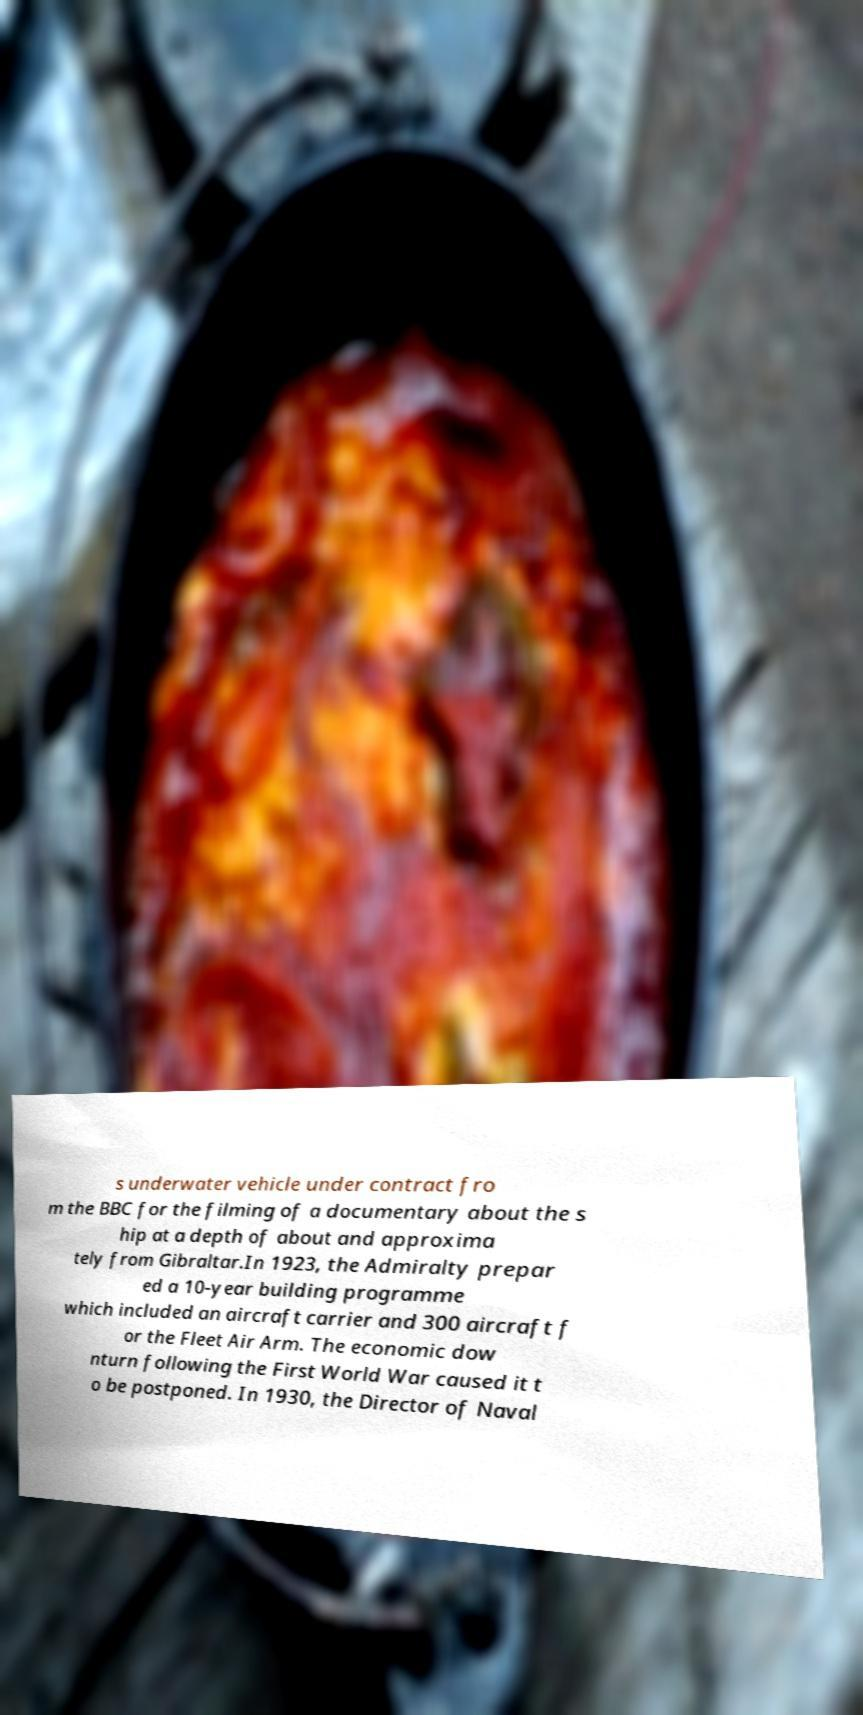Please identify and transcribe the text found in this image. s underwater vehicle under contract fro m the BBC for the filming of a documentary about the s hip at a depth of about and approxima tely from Gibraltar.In 1923, the Admiralty prepar ed a 10-year building programme which included an aircraft carrier and 300 aircraft f or the Fleet Air Arm. The economic dow nturn following the First World War caused it t o be postponed. In 1930, the Director of Naval 